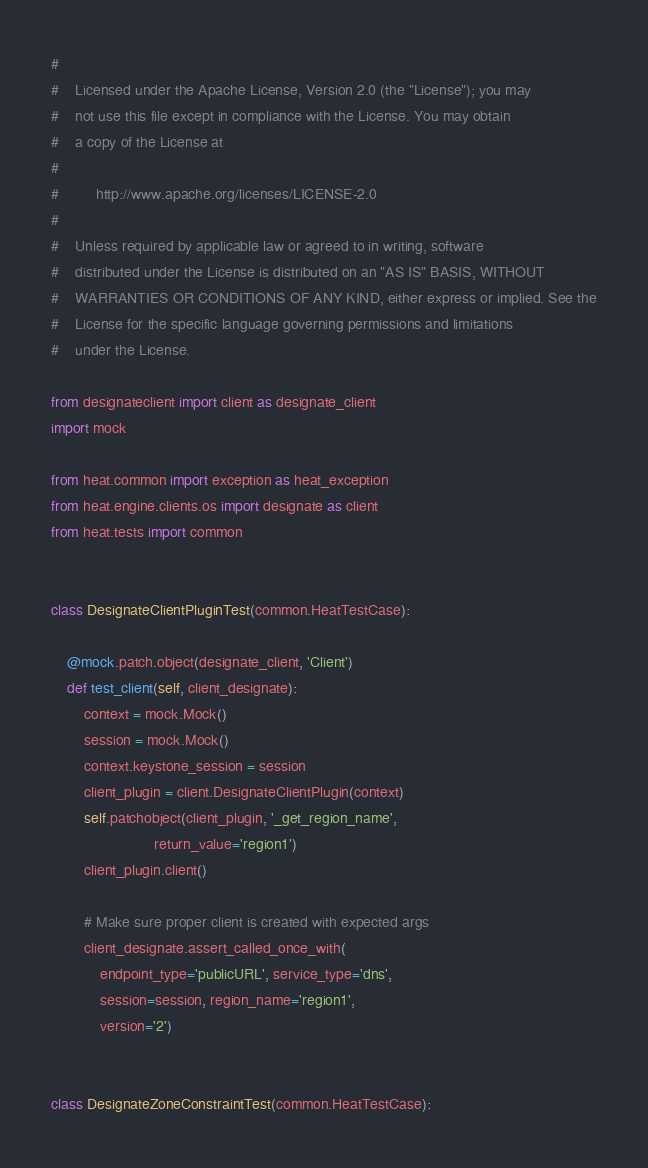<code> <loc_0><loc_0><loc_500><loc_500><_Python_>#
#    Licensed under the Apache License, Version 2.0 (the "License"); you may
#    not use this file except in compliance with the License. You may obtain
#    a copy of the License at
#
#         http://www.apache.org/licenses/LICENSE-2.0
#
#    Unless required by applicable law or agreed to in writing, software
#    distributed under the License is distributed on an "AS IS" BASIS, WITHOUT
#    WARRANTIES OR CONDITIONS OF ANY KIND, either express or implied. See the
#    License for the specific language governing permissions and limitations
#    under the License.

from designateclient import client as designate_client
import mock

from heat.common import exception as heat_exception
from heat.engine.clients.os import designate as client
from heat.tests import common


class DesignateClientPluginTest(common.HeatTestCase):

    @mock.patch.object(designate_client, 'Client')
    def test_client(self, client_designate):
        context = mock.Mock()
        session = mock.Mock()
        context.keystone_session = session
        client_plugin = client.DesignateClientPlugin(context)
        self.patchobject(client_plugin, '_get_region_name',
                         return_value='region1')
        client_plugin.client()

        # Make sure proper client is created with expected args
        client_designate.assert_called_once_with(
            endpoint_type='publicURL', service_type='dns',
            session=session, region_name='region1',
            version='2')


class DesignateZoneConstraintTest(common.HeatTestCase):
</code> 